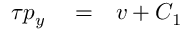<formula> <loc_0><loc_0><loc_500><loc_500>\begin{array} { r l r } { \tau p _ { y } } & = } & { v + C _ { 1 } } \end{array}</formula> 